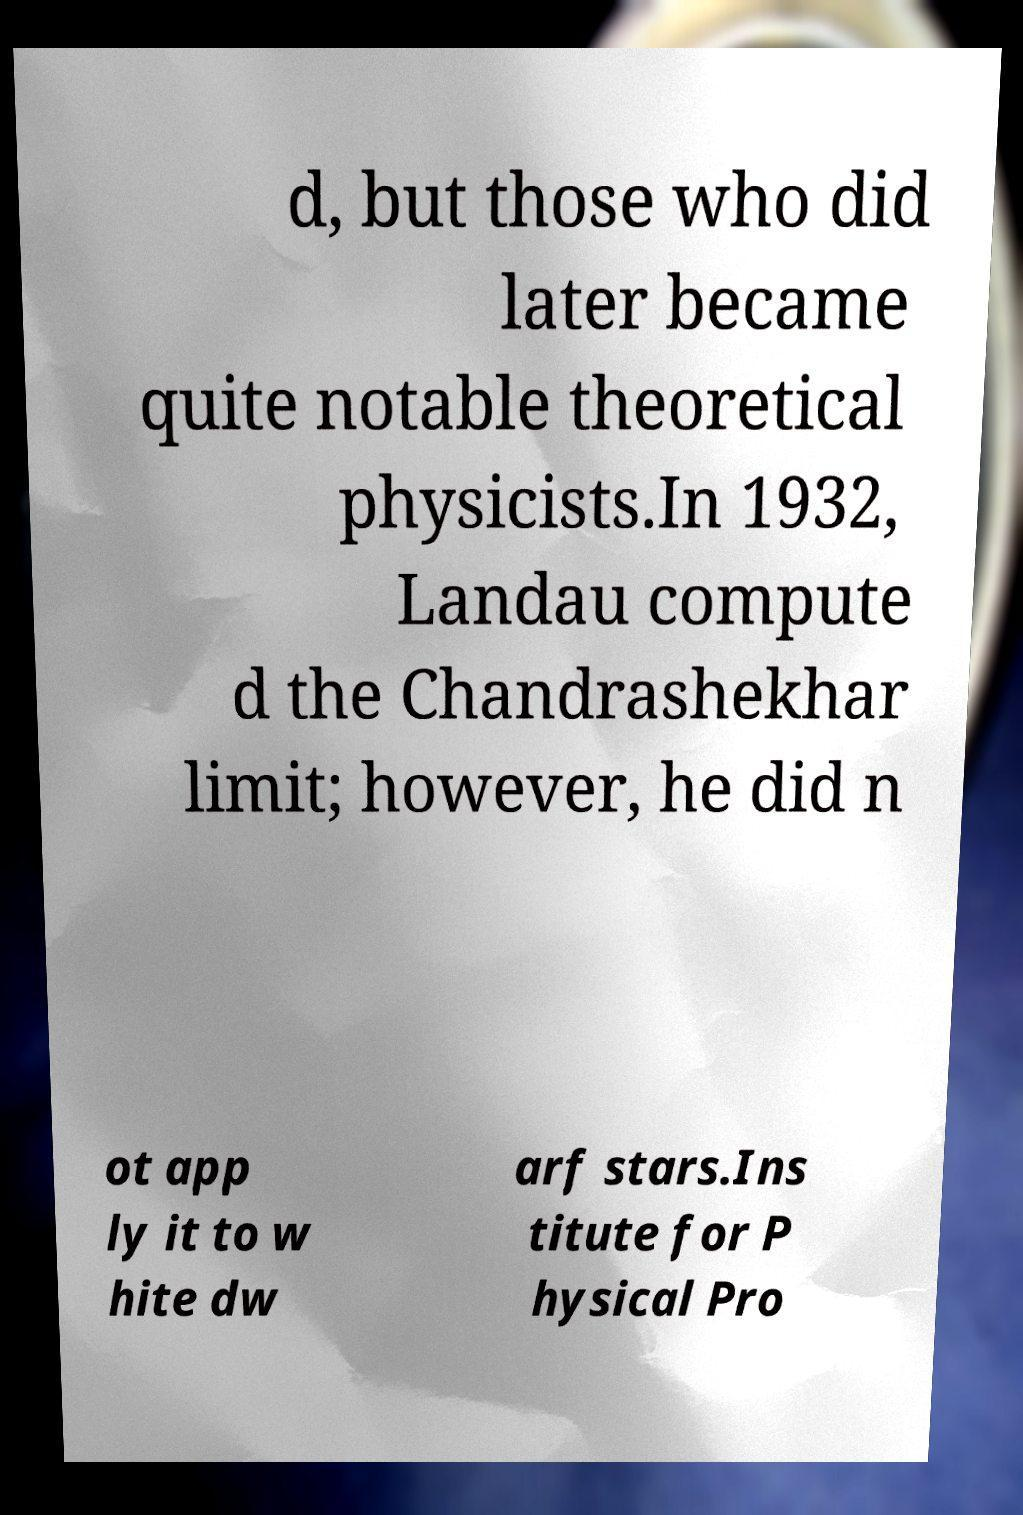Please identify and transcribe the text found in this image. d, but those who did later became quite notable theoretical physicists.In 1932, Landau compute d the Chandrashekhar limit; however, he did n ot app ly it to w hite dw arf stars.Ins titute for P hysical Pro 